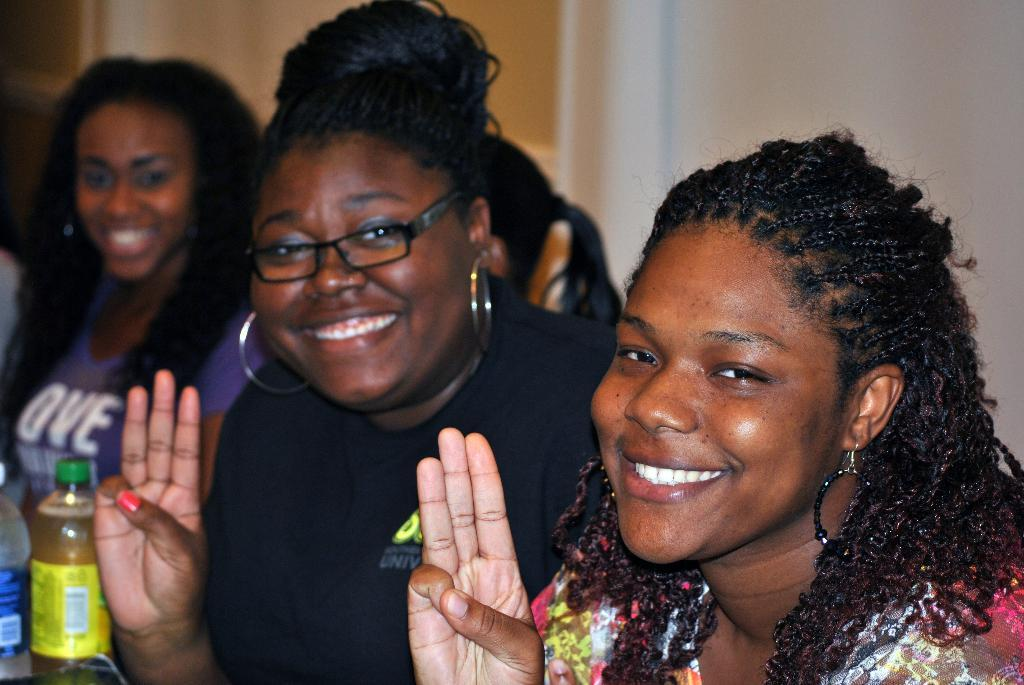How many people are in the image? There are three women in the image. What can be seen on the left side of the image? There are two bottles on the left side of the image. What is visible in the background of the image? There is a wall in the background of the image. What type of bird is perched on the shoulder of one of the women in the image? There are no birds present in the image. What is the nature of the competition between the three women in the image? There is no competition depicted in the image; it simply shows three women. 